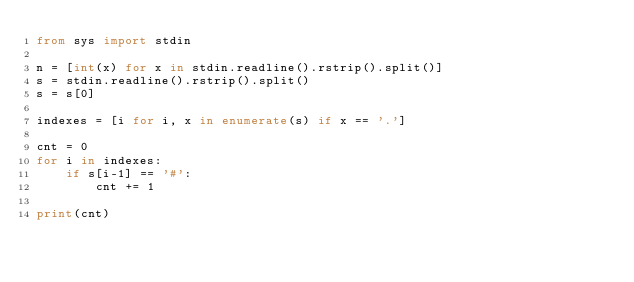Convert code to text. <code><loc_0><loc_0><loc_500><loc_500><_Python_>from sys import stdin

n = [int(x) for x in stdin.readline().rstrip().split()]
s = stdin.readline().rstrip().split()
s = s[0]

indexes = [i for i, x in enumerate(s) if x == '.']

cnt = 0
for i in indexes:
    if s[i-1] == '#':
        cnt += 1

print(cnt)
</code> 